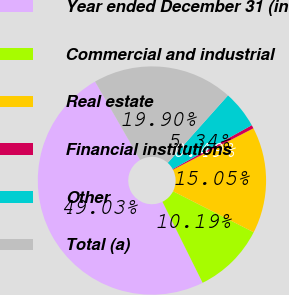<chart> <loc_0><loc_0><loc_500><loc_500><pie_chart><fcel>Year ended December 31 (in<fcel>Commercial and industrial<fcel>Real estate<fcel>Financial institutions<fcel>Other<fcel>Total (a)<nl><fcel>49.03%<fcel>10.19%<fcel>15.05%<fcel>0.49%<fcel>5.34%<fcel>19.9%<nl></chart> 